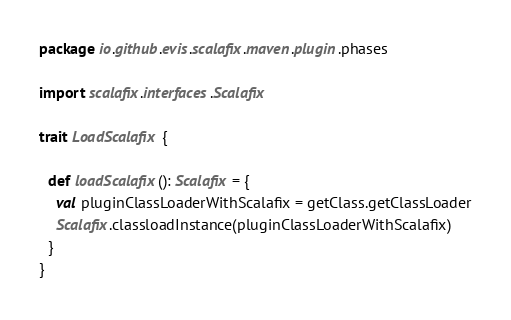<code> <loc_0><loc_0><loc_500><loc_500><_Scala_>package io.github.evis.scalafix.maven.plugin.phases

import scalafix.interfaces.Scalafix

trait LoadScalafix {

  def loadScalafix(): Scalafix = {
    val pluginClassLoaderWithScalafix = getClass.getClassLoader
    Scalafix.classloadInstance(pluginClassLoaderWithScalafix)
  }
}
</code> 